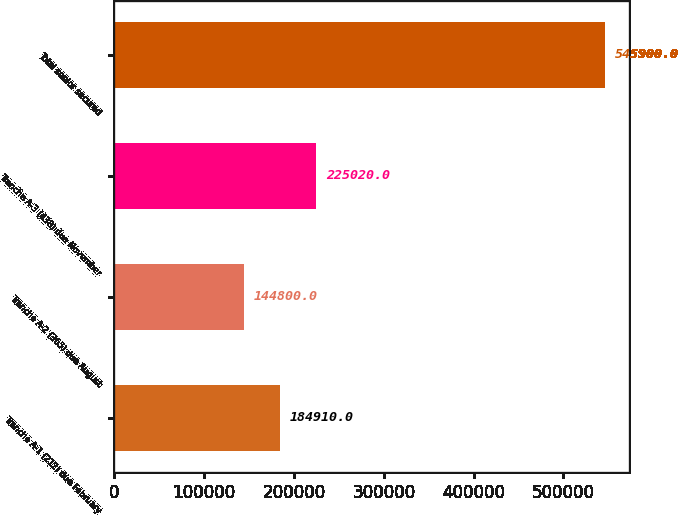<chart> <loc_0><loc_0><loc_500><loc_500><bar_chart><fcel>Tranche A-1 (212) due February<fcel>Tranche A-2 (365) due August<fcel>Tranche A-3 (438) due November<fcel>Total senior secured<nl><fcel>184910<fcel>144800<fcel>225020<fcel>545900<nl></chart> 